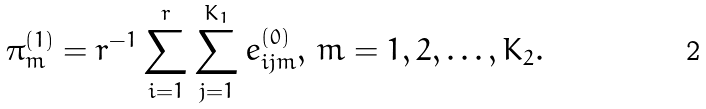Convert formula to latex. <formula><loc_0><loc_0><loc_500><loc_500>\pi _ { m } ^ { ( 1 ) } = r ^ { - 1 } \sum _ { i = 1 } ^ { r } \sum _ { j = 1 } ^ { K _ { 1 } } e ^ { ( 0 ) } _ { i j m } , \, m = 1 , 2 , \dots , K _ { 2 } .</formula> 